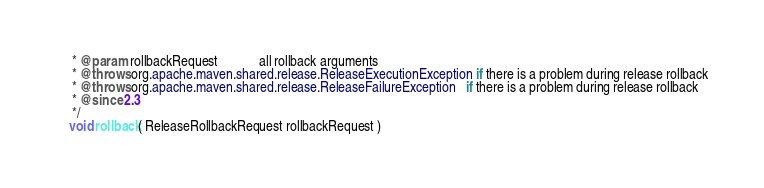Convert code to text. <code><loc_0><loc_0><loc_500><loc_500><_Java_>     * @param rollbackRequest            all rollback arguments
     * @throws org.apache.maven.shared.release.ReleaseExecutionException if there is a problem during release rollback
     * @throws org.apache.maven.shared.release.ReleaseFailureException   if there is a problem during release rollback
     * @since 2.3
     */
    void rollback( ReleaseRollbackRequest rollbackRequest )</code> 